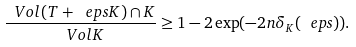Convert formula to latex. <formula><loc_0><loc_0><loc_500><loc_500>\frac { \ V o l { ( T + \ e p s K ) \cap K } } { \ V o l { K } } \geq 1 - 2 \exp ( - 2 n \delta _ { K } ( \ e p s ) ) .</formula> 